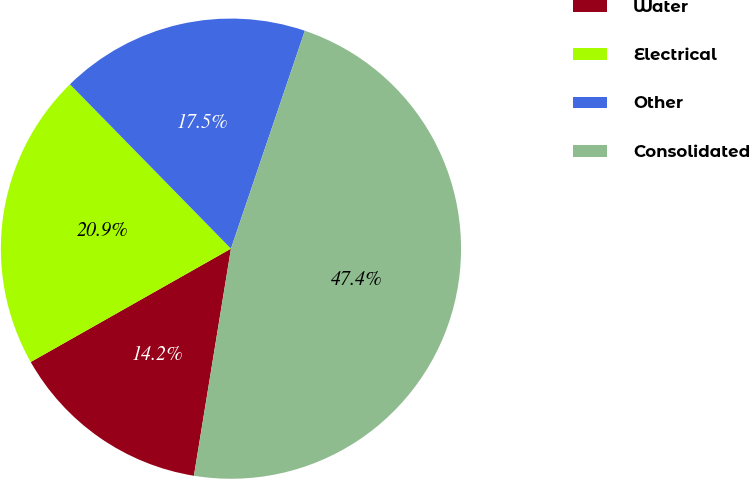Convert chart to OTSL. <chart><loc_0><loc_0><loc_500><loc_500><pie_chart><fcel>Water<fcel>Electrical<fcel>Other<fcel>Consolidated<nl><fcel>14.23%<fcel>20.86%<fcel>17.54%<fcel>47.37%<nl></chart> 